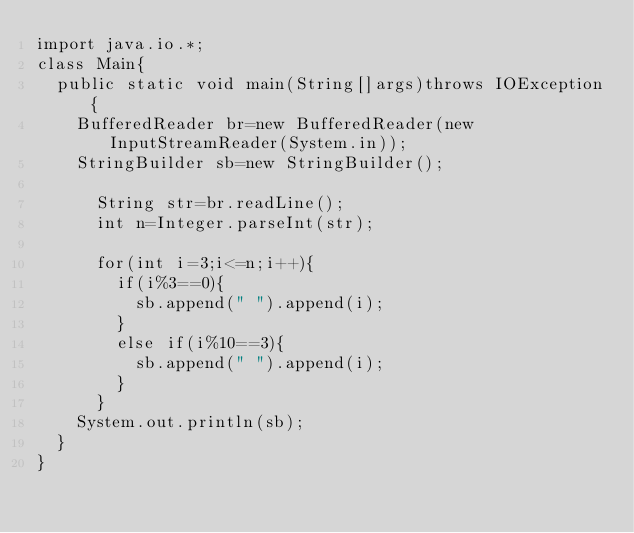Convert code to text. <code><loc_0><loc_0><loc_500><loc_500><_Java_>import java.io.*;
class Main{
	public static void main(String[]args)throws IOException{
		BufferedReader br=new BufferedReader(new InputStreamReader(System.in));
		StringBuilder sb=new StringBuilder();
		
			String str=br.readLine();
			int n=Integer.parseInt(str);
			
			for(int i=3;i<=n;i++){
				if(i%3==0){
					sb.append(" ").append(i);
				}
				else if(i%10==3){
					sb.append(" ").append(i);
				}
			}
		System.out.println(sb);
	}
}</code> 